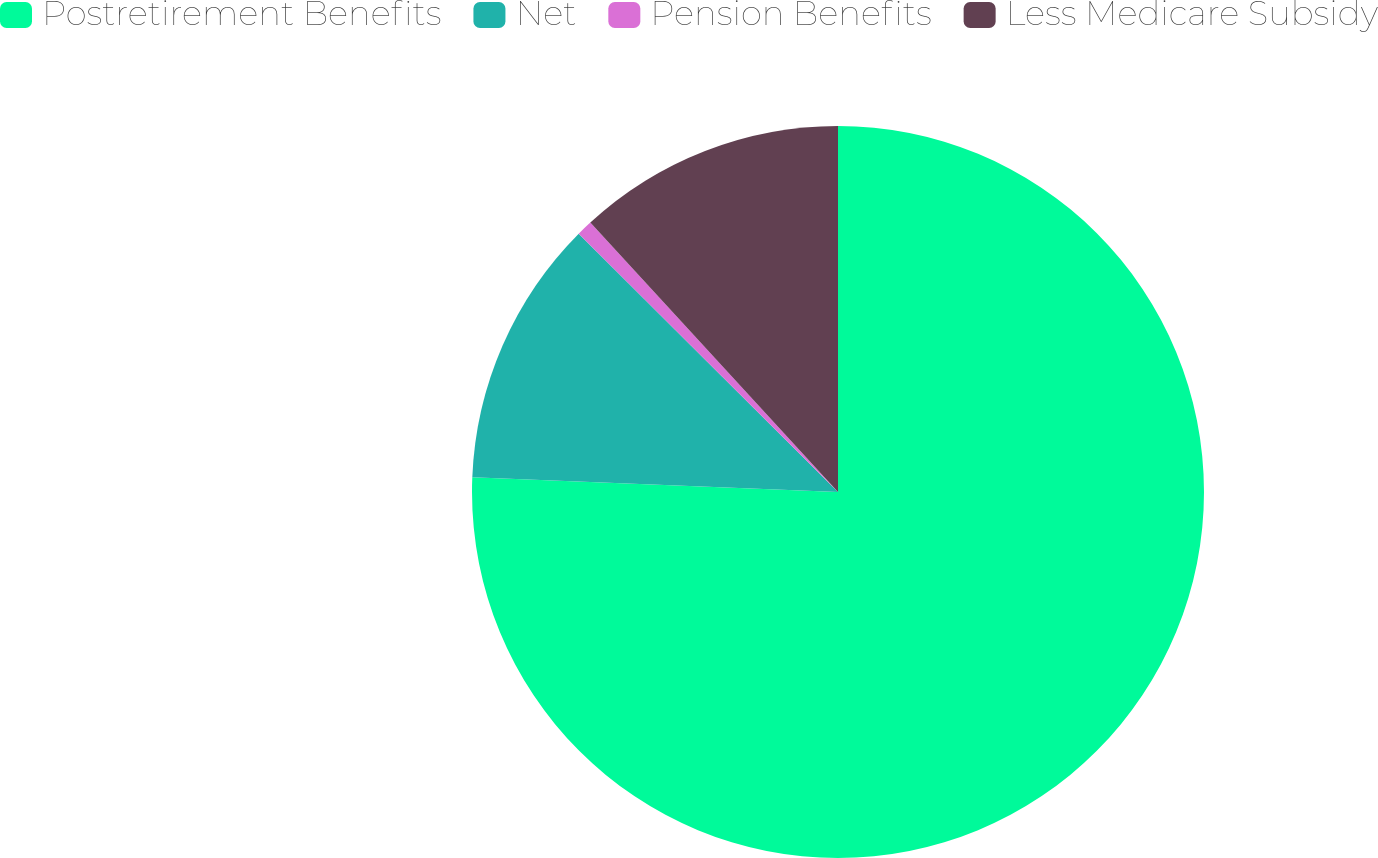<chart> <loc_0><loc_0><loc_500><loc_500><pie_chart><fcel>Postretirement Benefits<fcel>Net<fcel>Pension Benefits<fcel>Less Medicare Subsidy<nl><fcel>75.64%<fcel>11.83%<fcel>0.7%<fcel>11.83%<nl></chart> 